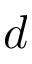Convert formula to latex. <formula><loc_0><loc_0><loc_500><loc_500>d</formula> 